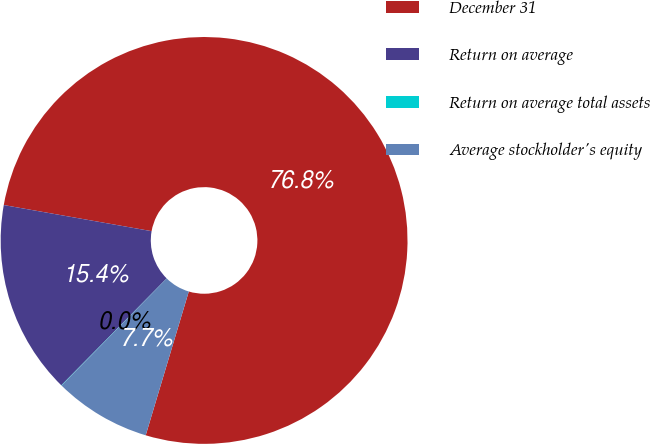Convert chart. <chart><loc_0><loc_0><loc_500><loc_500><pie_chart><fcel>December 31<fcel>Return on average<fcel>Return on average total assets<fcel>Average stockholder's equity<nl><fcel>76.85%<fcel>15.4%<fcel>0.03%<fcel>7.72%<nl></chart> 